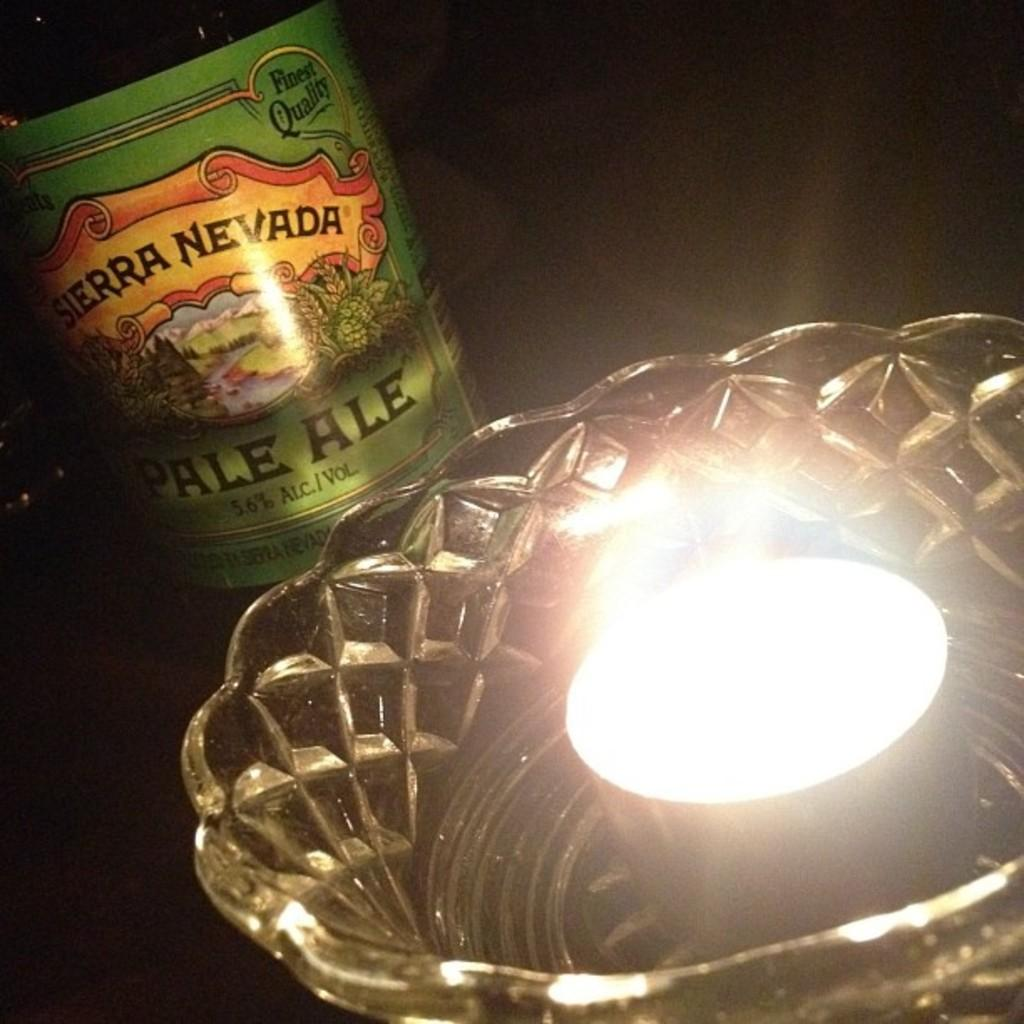What is the main subject in the image? There is a light in a bowl in the image. What else can be seen in the background of the image? There is a bottle in the background of the image. Can you describe the bottle? The bottle has a green color and text on it. How would you describe the overall lighting in the image? The background of the image is dark. How many pieces of fruit are hanging from the hook in the image? There is no hook or fruit present in the image. 